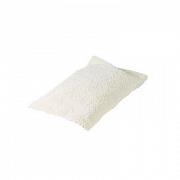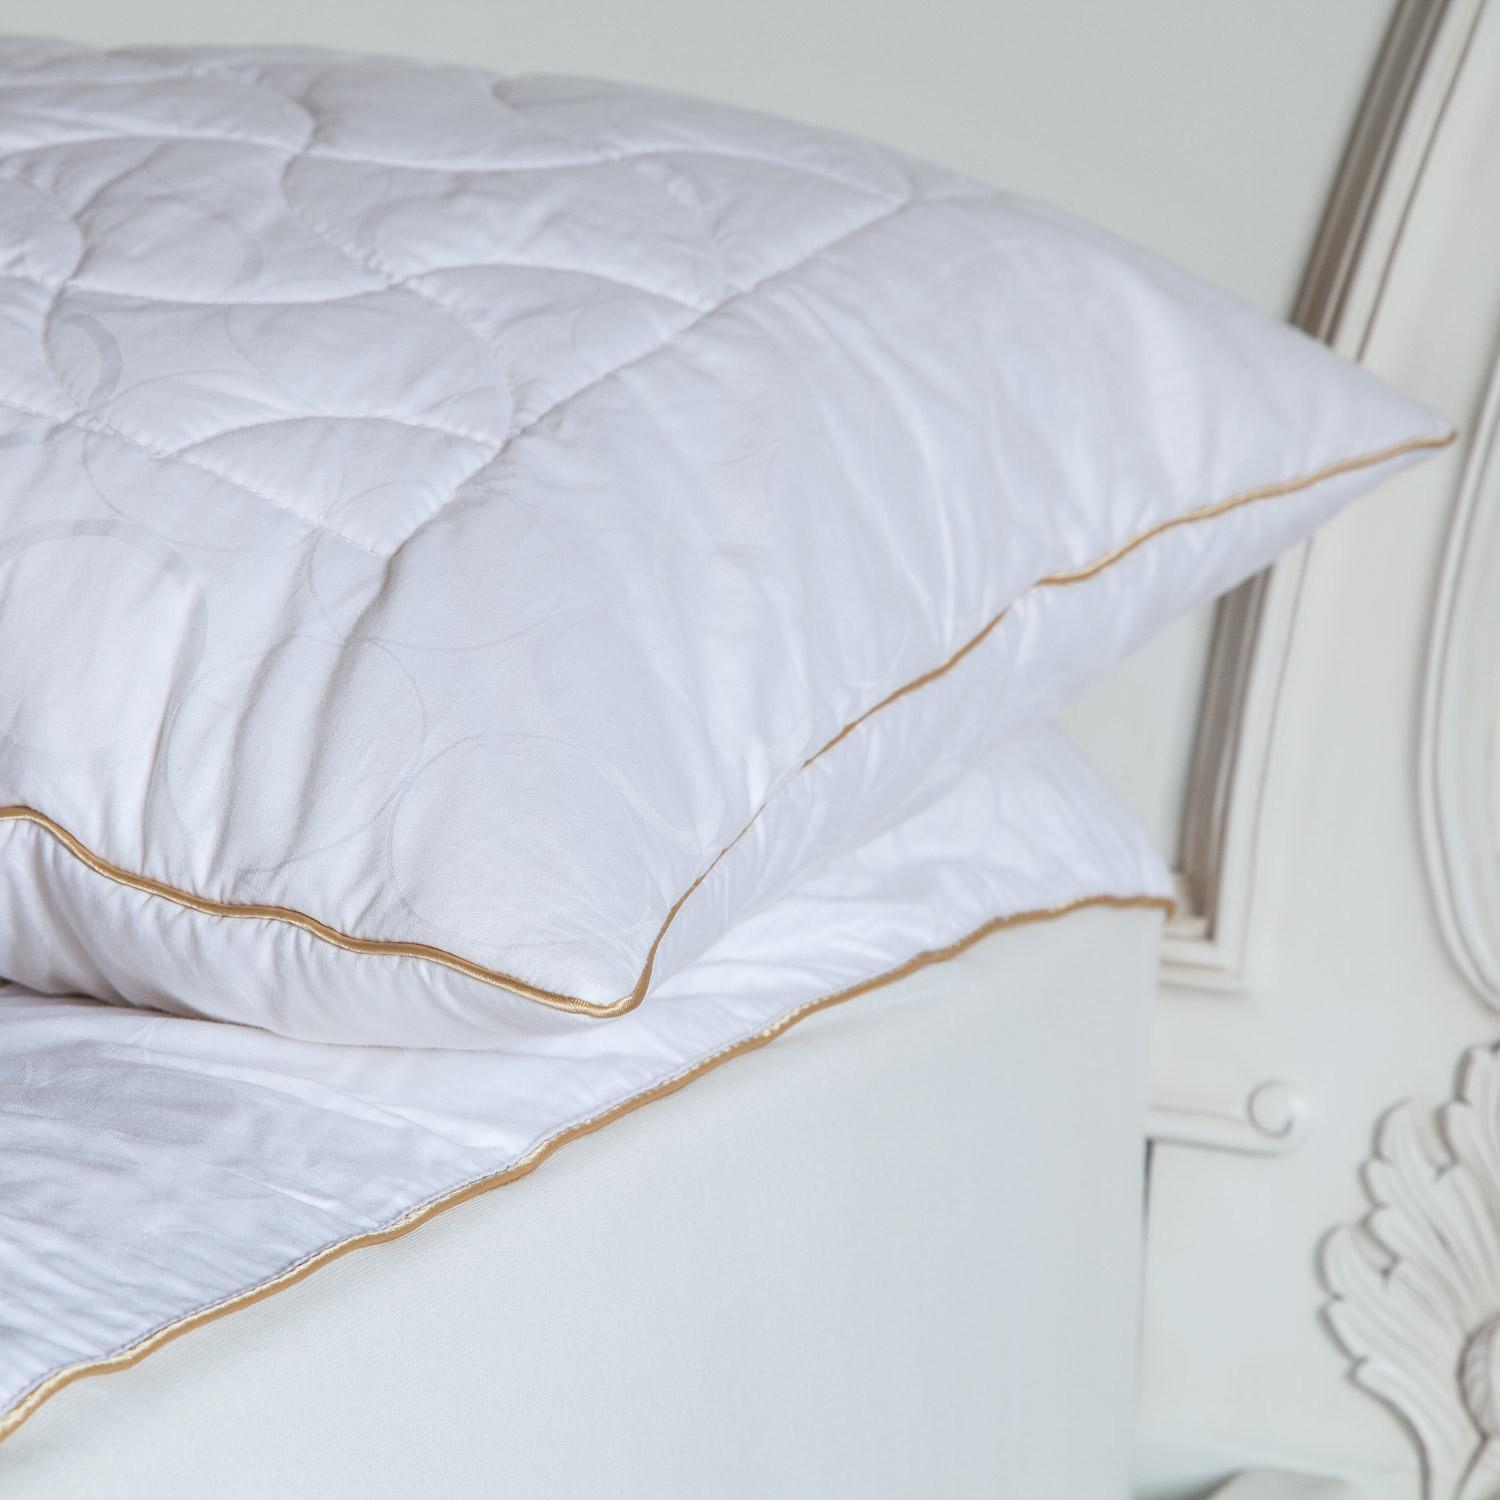The first image is the image on the left, the second image is the image on the right. Examine the images to the left and right. Is the description "The left image contains a single item." accurate? Answer yes or no. Yes. 